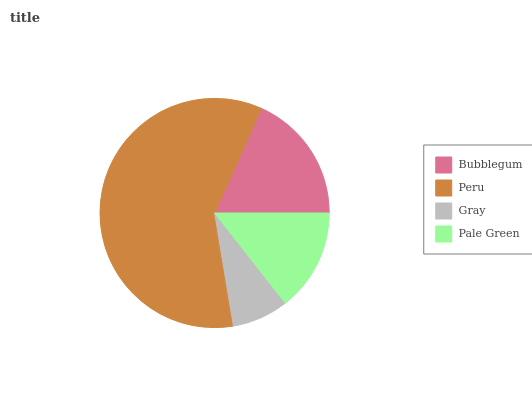Is Gray the minimum?
Answer yes or no. Yes. Is Peru the maximum?
Answer yes or no. Yes. Is Peru the minimum?
Answer yes or no. No. Is Gray the maximum?
Answer yes or no. No. Is Peru greater than Gray?
Answer yes or no. Yes. Is Gray less than Peru?
Answer yes or no. Yes. Is Gray greater than Peru?
Answer yes or no. No. Is Peru less than Gray?
Answer yes or no. No. Is Bubblegum the high median?
Answer yes or no. Yes. Is Pale Green the low median?
Answer yes or no. Yes. Is Pale Green the high median?
Answer yes or no. No. Is Peru the low median?
Answer yes or no. No. 